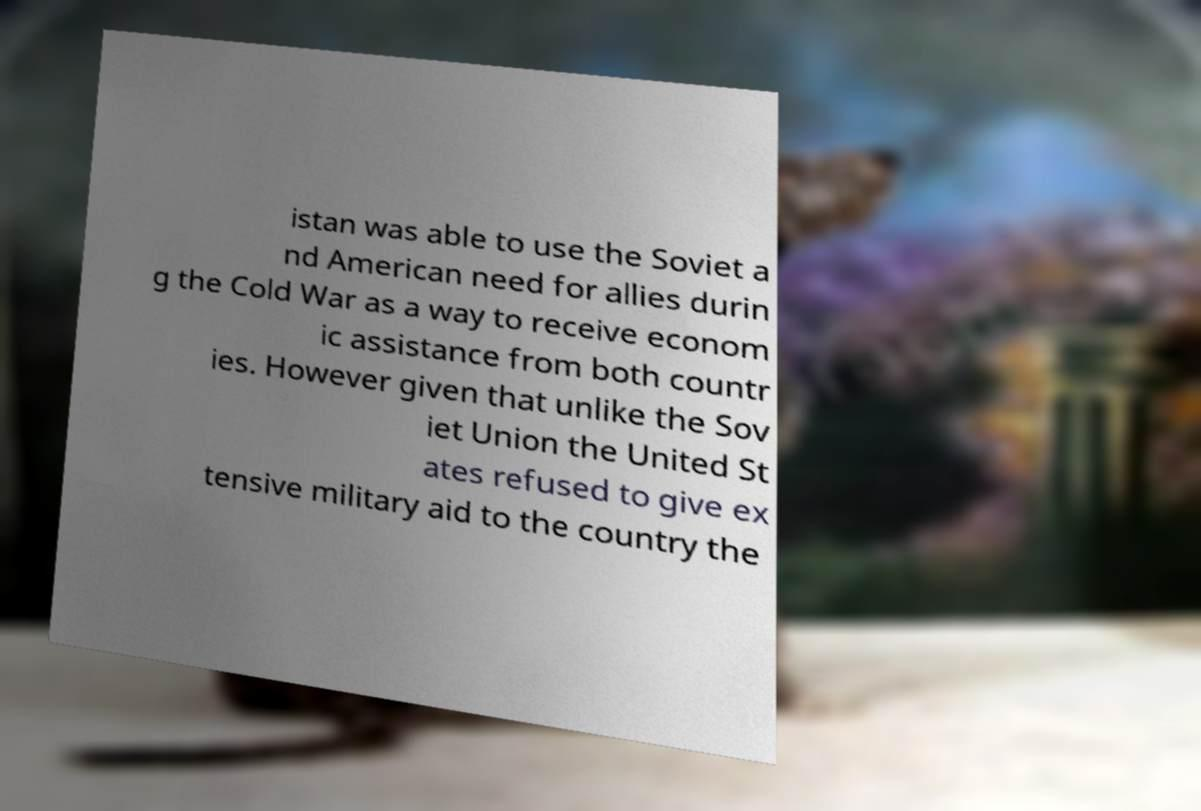Please identify and transcribe the text found in this image. istan was able to use the Soviet a nd American need for allies durin g the Cold War as a way to receive econom ic assistance from both countr ies. However given that unlike the Sov iet Union the United St ates refused to give ex tensive military aid to the country the 